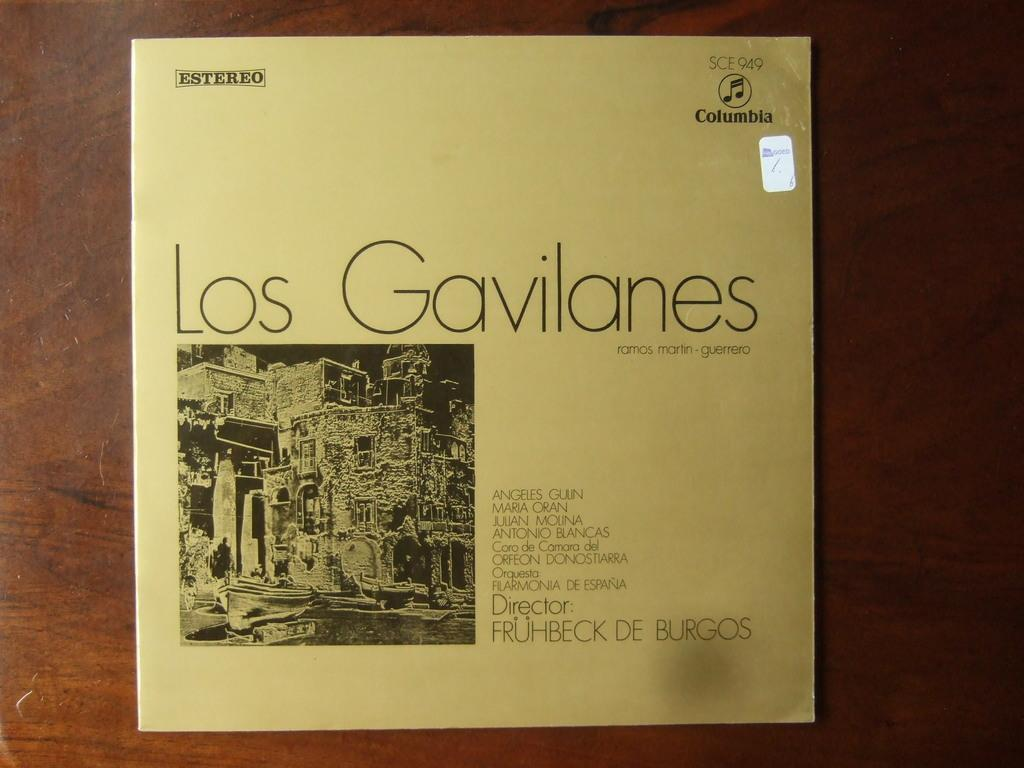<image>
Render a clear and concise summary of the photo. An album of Los Gavilanes placed on a dark brown table. 